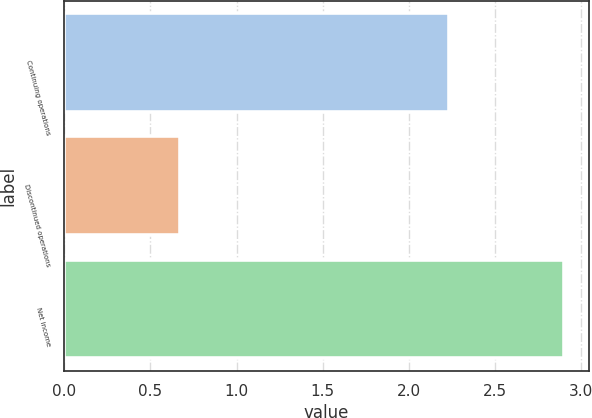Convert chart. <chart><loc_0><loc_0><loc_500><loc_500><bar_chart><fcel>Continuing operations<fcel>Discontinued operations<fcel>Net income<nl><fcel>2.23<fcel>0.67<fcel>2.9<nl></chart> 